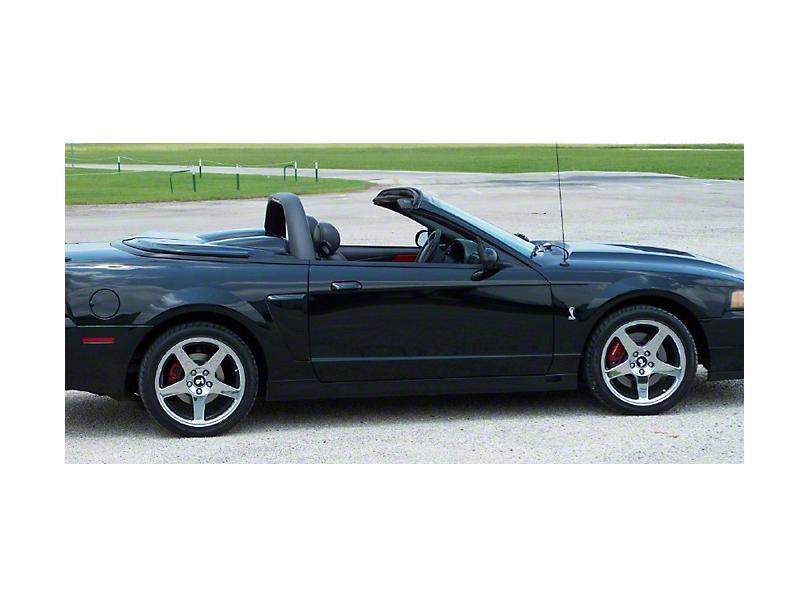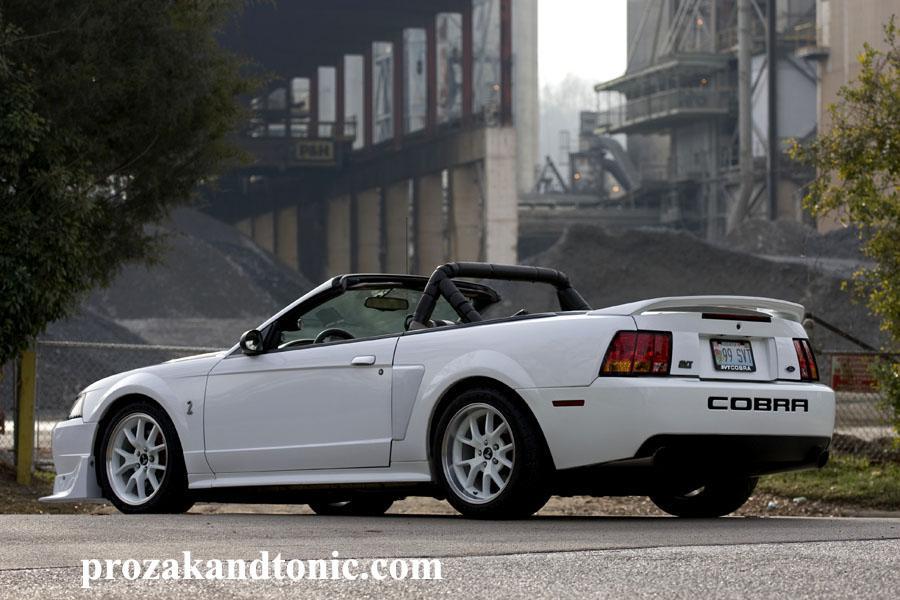The first image is the image on the left, the second image is the image on the right. Assess this claim about the two images: "A white car is parked on the road in one of the images.". Correct or not? Answer yes or no. Yes. The first image is the image on the left, the second image is the image on the right. For the images displayed, is the sentence "An image shows a white topless convertible displayed parked at an angle on pavement." factually correct? Answer yes or no. Yes. 